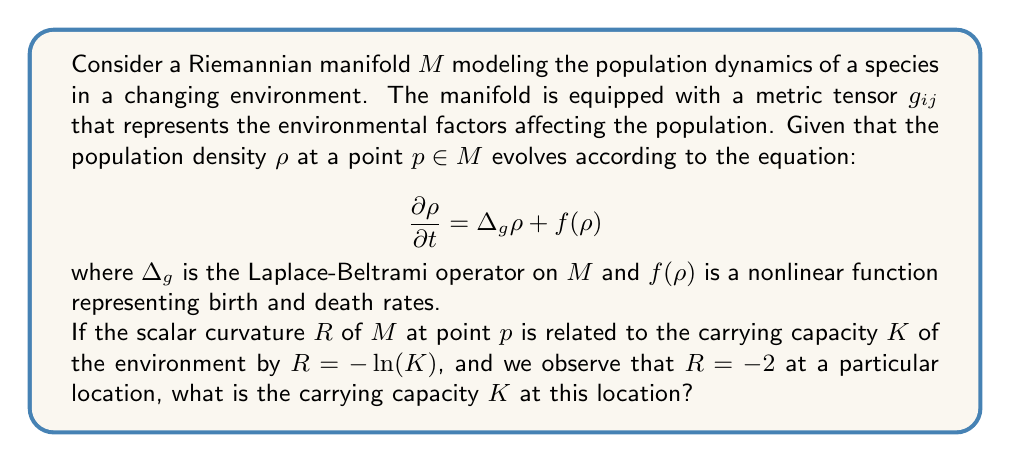Help me with this question. To solve this problem, we need to understand the relationship between the scalar curvature $R$ and the carrying capacity $K$, and then use the given information to calculate $K$.

1. We are given that the scalar curvature $R$ is related to the carrying capacity $K$ by the equation:

   $$R = -\ln(K)$$

2. At a particular location, we observe that $R = -2$. We can substitute this value into the equation:

   $$-2 = -\ln(K)$$

3. To solve for $K$, we need to apply the exponential function to both sides of the equation. This is because the exponential function is the inverse of the natural logarithm:

   $$e^{-2} = e^{-\ln(K)}$$

4. The right-hand side simplifies due to the properties of exponentials and logarithms:

   $$e^{-2} = \frac{1}{K}$$

5. Now we can solve for $K$ by taking the reciprocal of both sides:

   $$K = \frac{1}{e^{-2}}$$

6. We can simplify this further:

   $$K = e^2$$

7. The value of $e^2$ is approximately 7.389, but in the context of population dynamics, it's more appropriate to round to a whole number.

This result indicates that the carrying capacity $K$ at the location where $R = -2$ is approximately 7 individuals (rounded to the nearest whole number).

From a zoological perspective, this carrying capacity represents the maximum sustainable population size that the environment can support at this specific location, given the current environmental conditions as encoded in the Riemannian metric of the manifold.
Answer: The carrying capacity $K$ at the location where $R = -2$ is $e^2 \approx 7$ individuals (rounded to the nearest whole number). 